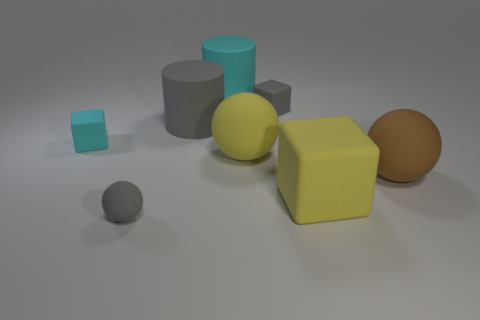Do the brown rubber object and the big cyan rubber thing have the same shape?
Your answer should be compact. No. What is the size of the matte block that is the same color as the tiny sphere?
Keep it short and to the point. Small. There is a big thing behind the gray matte object that is to the right of the large yellow rubber ball; what shape is it?
Give a very brief answer. Cylinder. Do the big cyan object and the gray object on the right side of the large cyan rubber cylinder have the same shape?
Provide a short and direct response. No. There is a block that is the same size as the gray cylinder; what is its color?
Ensure brevity in your answer.  Yellow. Is the number of gray rubber cylinders in front of the small cyan rubber cube less than the number of large gray matte objects to the right of the brown ball?
Ensure brevity in your answer.  No. What shape is the yellow rubber thing that is to the left of the small gray matte thing behind the tiny gray rubber thing left of the big cyan rubber cylinder?
Keep it short and to the point. Sphere. There is a rubber ball on the left side of the gray cylinder; is it the same color as the matte ball on the right side of the big block?
Keep it short and to the point. No. What shape is the large matte thing that is the same color as the big rubber cube?
Keep it short and to the point. Sphere. How many shiny things are big purple objects or cyan blocks?
Your answer should be compact. 0. 